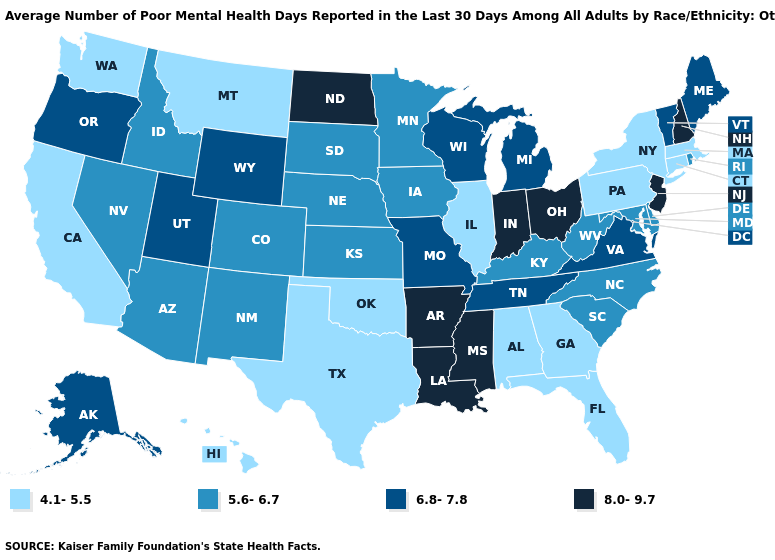What is the highest value in the West ?
Concise answer only. 6.8-7.8. Among the states that border Rhode Island , which have the lowest value?
Be succinct. Connecticut, Massachusetts. What is the value of Maryland?
Answer briefly. 5.6-6.7. Name the states that have a value in the range 6.8-7.8?
Keep it brief. Alaska, Maine, Michigan, Missouri, Oregon, Tennessee, Utah, Vermont, Virginia, Wisconsin, Wyoming. Name the states that have a value in the range 4.1-5.5?
Concise answer only. Alabama, California, Connecticut, Florida, Georgia, Hawaii, Illinois, Massachusetts, Montana, New York, Oklahoma, Pennsylvania, Texas, Washington. What is the value of New Jersey?
Write a very short answer. 8.0-9.7. Name the states that have a value in the range 6.8-7.8?
Quick response, please. Alaska, Maine, Michigan, Missouri, Oregon, Tennessee, Utah, Vermont, Virginia, Wisconsin, Wyoming. What is the highest value in the USA?
Quick response, please. 8.0-9.7. Does Missouri have the same value as Nevada?
Quick response, please. No. What is the lowest value in the Northeast?
Short answer required. 4.1-5.5. Name the states that have a value in the range 5.6-6.7?
Quick response, please. Arizona, Colorado, Delaware, Idaho, Iowa, Kansas, Kentucky, Maryland, Minnesota, Nebraska, Nevada, New Mexico, North Carolina, Rhode Island, South Carolina, South Dakota, West Virginia. Does Montana have a higher value than Alabama?
Short answer required. No. Which states have the lowest value in the South?
Keep it brief. Alabama, Florida, Georgia, Oklahoma, Texas. Name the states that have a value in the range 5.6-6.7?
Short answer required. Arizona, Colorado, Delaware, Idaho, Iowa, Kansas, Kentucky, Maryland, Minnesota, Nebraska, Nevada, New Mexico, North Carolina, Rhode Island, South Carolina, South Dakota, West Virginia. 